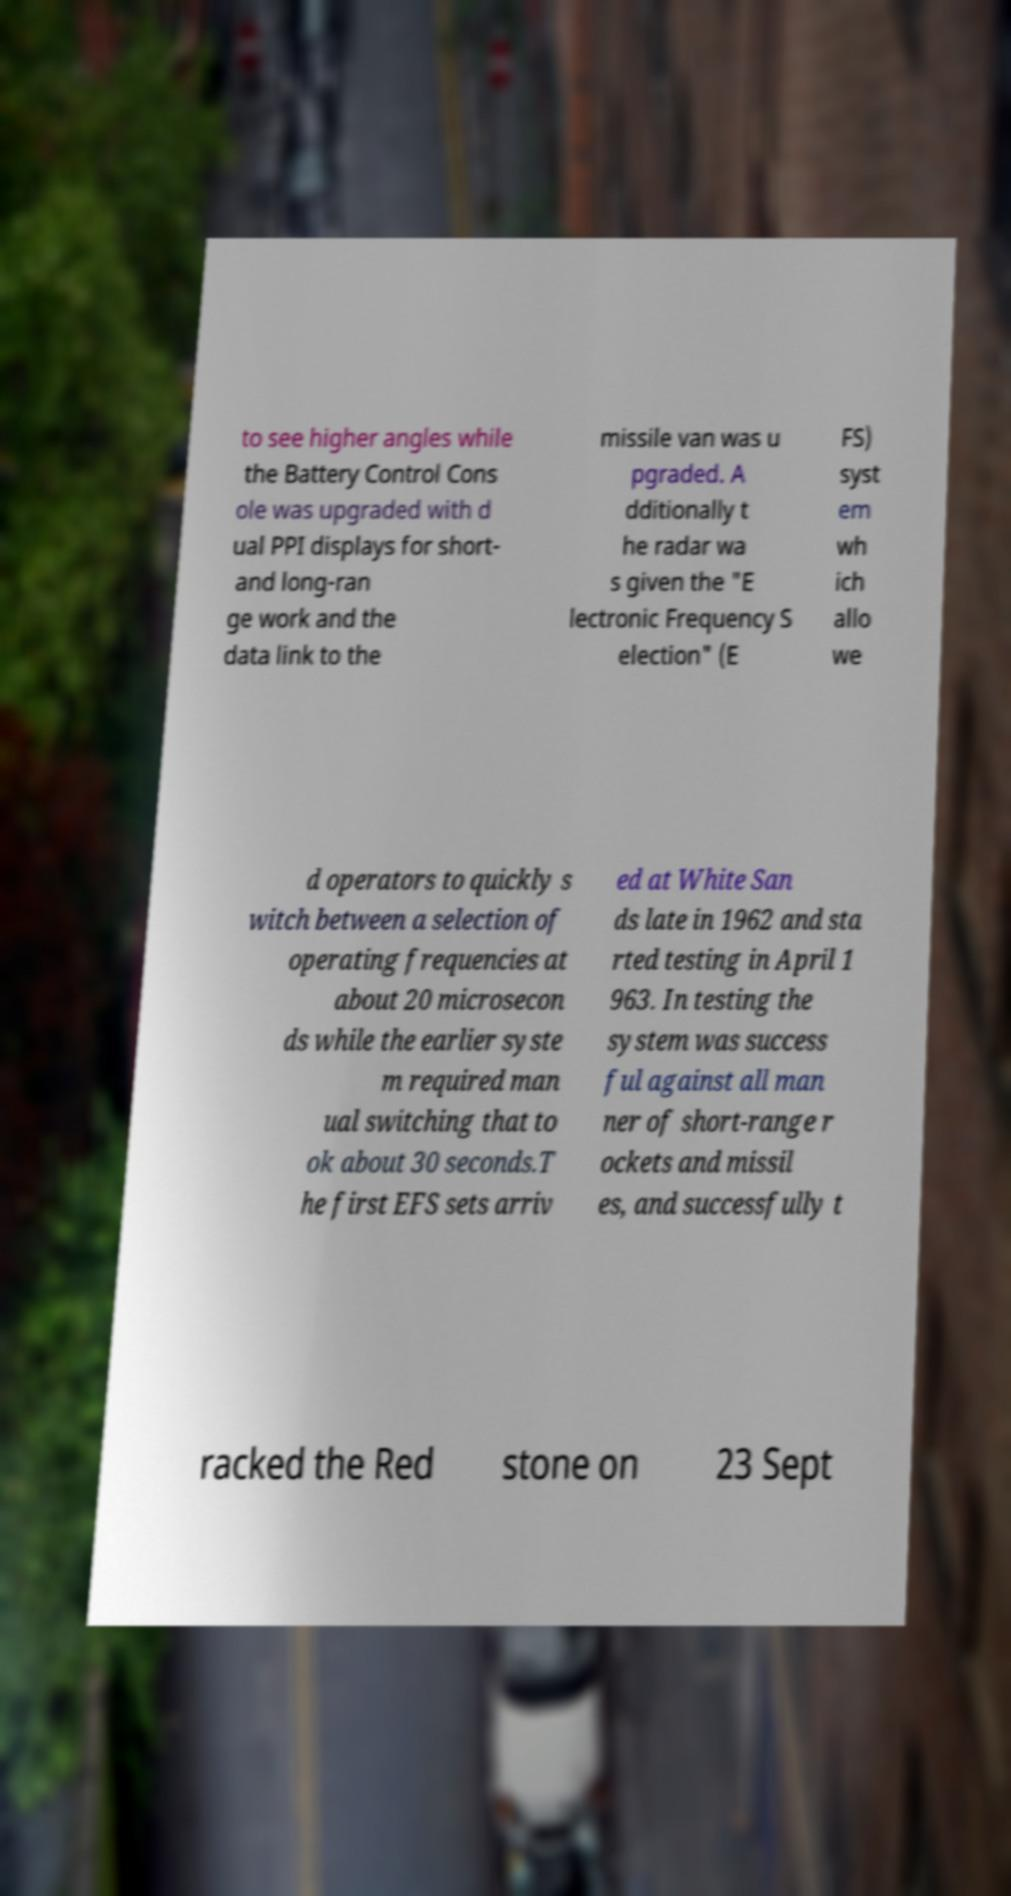There's text embedded in this image that I need extracted. Can you transcribe it verbatim? to see higher angles while the Battery Control Cons ole was upgraded with d ual PPI displays for short- and long-ran ge work and the data link to the missile van was u pgraded. A dditionally t he radar wa s given the "E lectronic Frequency S election" (E FS) syst em wh ich allo we d operators to quickly s witch between a selection of operating frequencies at about 20 microsecon ds while the earlier syste m required man ual switching that to ok about 30 seconds.T he first EFS sets arriv ed at White San ds late in 1962 and sta rted testing in April 1 963. In testing the system was success ful against all man ner of short-range r ockets and missil es, and successfully t racked the Red stone on 23 Sept 